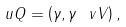<formula> <loc_0><loc_0><loc_500><loc_500>\ u Q = \left ( \gamma , \gamma \ v V \right ) ,</formula> 